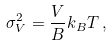<formula> <loc_0><loc_0><loc_500><loc_500>\sigma _ { V } ^ { 2 } = \frac { V } { B } k _ { B } T \, ,</formula> 